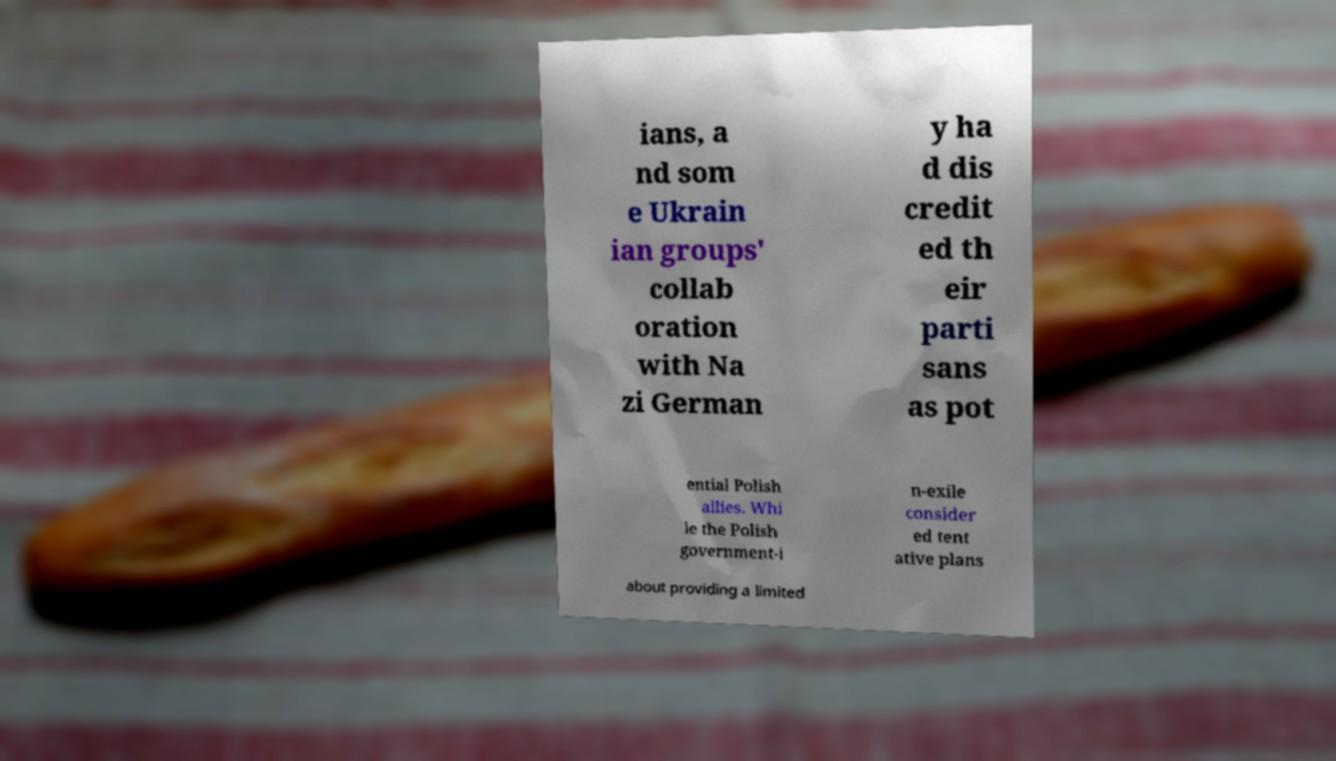Please identify and transcribe the text found in this image. ians, a nd som e Ukrain ian groups' collab oration with Na zi German y ha d dis credit ed th eir parti sans as pot ential Polish allies. Whi le the Polish government-i n-exile consider ed tent ative plans about providing a limited 